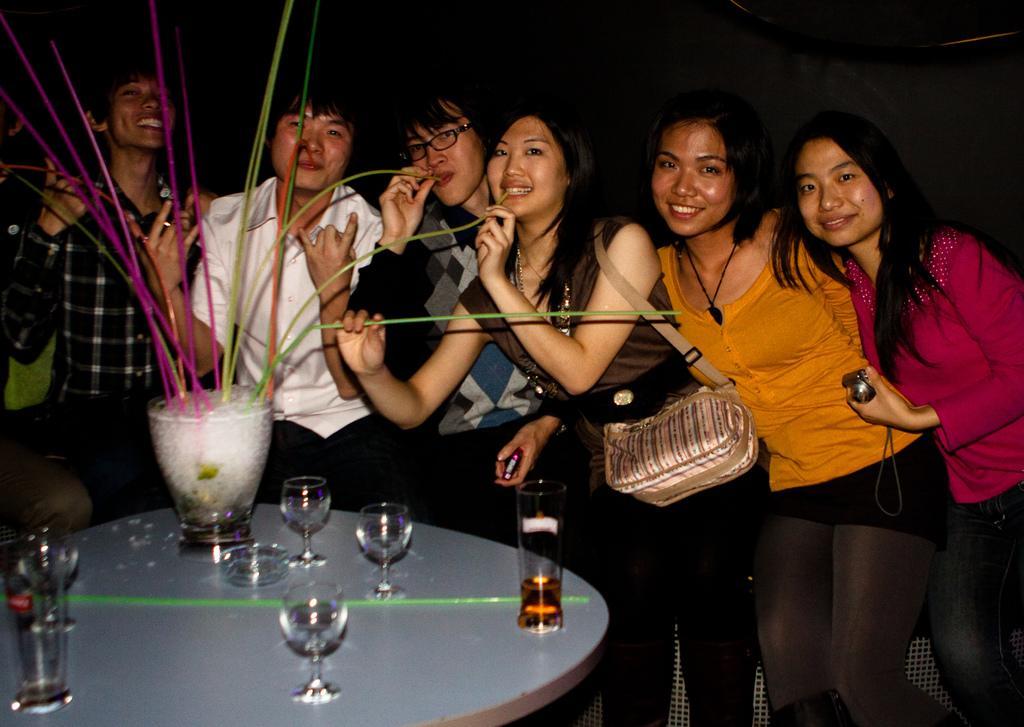How would you summarize this image in a sentence or two? Here we can see few person standing and giving pose to the camera and they are holding pretty smiles on their faces. Here on the table we can see glasses, drink in glass. This is a glass with ice cubes and straws. 